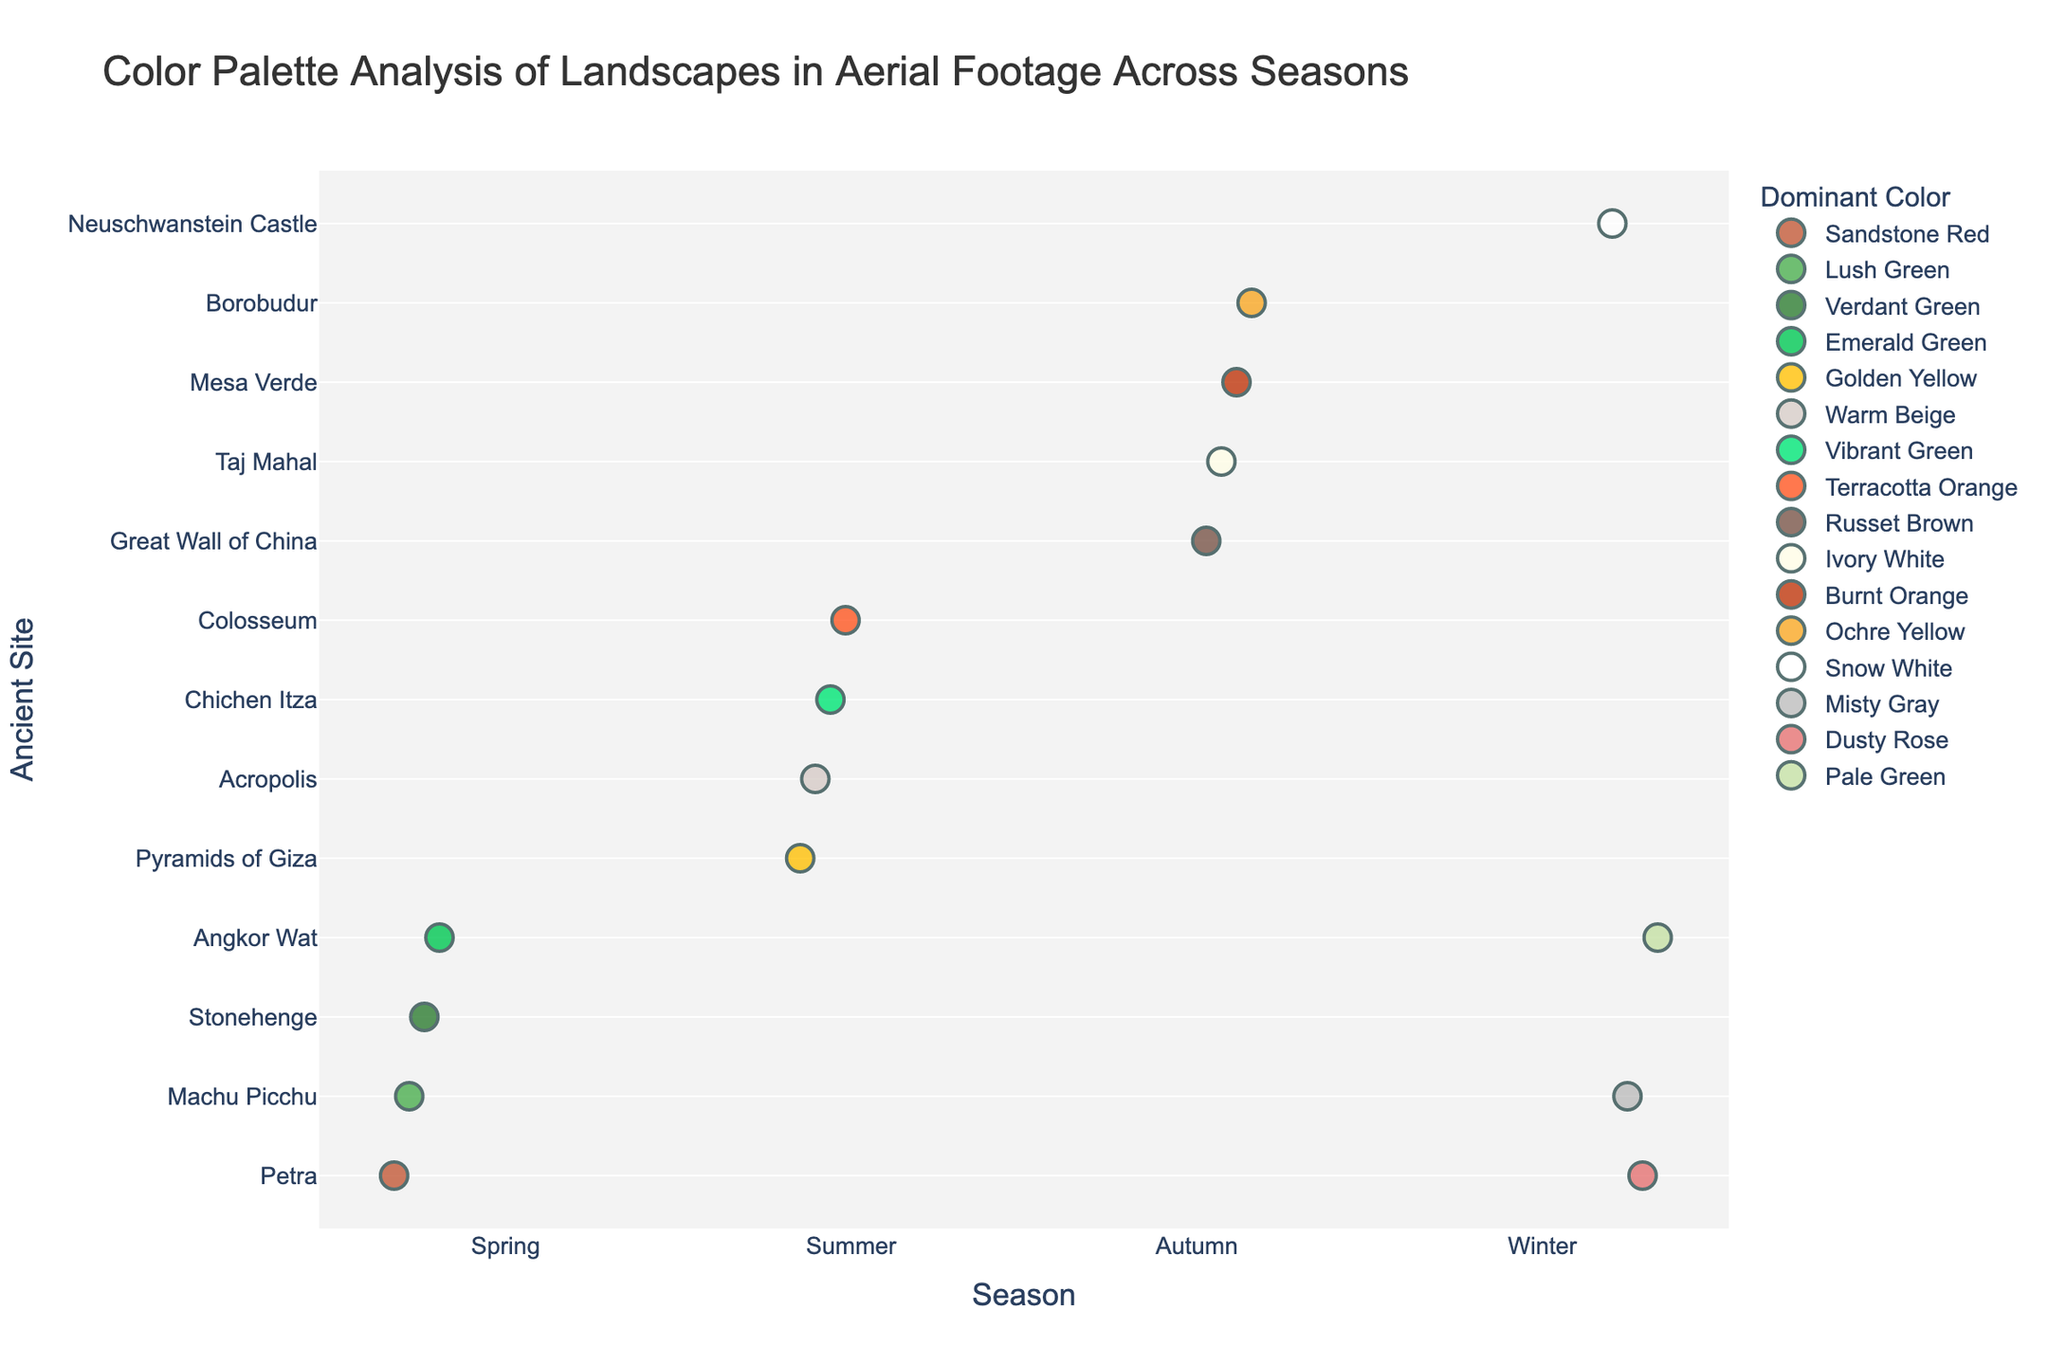What is the title of the plot? The title of the plot is displayed at the top center. It is "Color Palette Analysis of Landscapes in Aerial Footage Across Seasons."
Answer: Color Palette Analysis of Landscapes in Aerial Footage Across Seasons Which season has the most variety of dominant colors? We need to count the number of unique dominant colors in each season. Spring has 4 unique colors (Sandstone Red, Lush Green, Verdant Green, Emerald Green), Summer has 4 (Golden Yellow, Warm Beige, Vibrant Green, Terracotta Orange), Autumn has 4 (Russet Brown, Ivory White, Burnt Orange, Ochre Yellow), and Winter has 4 (Snow White, Misty Gray, Dusty Rose, Pale Green).
Answer: All seasons have the same variety Which ancient site recorded in summer has the warmest color? We can compare the dominant colors of summer. The warmest colors listed are golden yellow (Pyramids of Giza) and warm beige (Acropolis), and golden yellow is generally considered warmer.
Answer: Pyramids of Giza How many ancient sites have "green" as a dominant color in any season? Identify all entries with green-like colors (Lush Green, Verdant Green, Emerald Green, Vibrant Green, Pale Green). The sites are Machu Picchu, Stonehenge, Angkor Wat, Chichen Itza, Angkor Wat (in different seasons). There are 5 entries.
Answer: 5 What is the dominant color for Stonehenge in spring? Locate Stonehenge under the spring season; the corresponding dominant color is "Verdant Green."
Answer: Verdant Green Do any sites repeat in the different seasons, and if so, what are they? Go through the list and identify any repeated ancient sites. Machu Picchu and Petra appear in different seasons (Spring and Winter).
Answer: Machu Picchu and Petra Which dominant color appears only once in the entire dataset? Identify unique dominant colors throughout the dataset. Warm Beige (Acropolis), Ochre Yellow (Borobudur), Misty Gray (Machu Picchu), Dusty Rose (Petra) are the colors that appear only once.
Answer: Warm Beige, Ochre Yellow, Misty Gray, Dusty Rose Does Angkor Wat have the same dominant color in different seasons? Compare the dominant colors for Angkor Wat in spring and in winter. Angkor Wat appears in both Spring (Emerald Green) and Winter (Pale Green)
Answer: No What is the most common dominant color across all seasons? Count the frequency of each dominant color across all seasons. Each color appears exactly once, so there is no most common color.
Answer: No dominant color is most common Which season has the most instances of non-green dominant colors? Count the instances where the dominant color is not related to green for each season. Spring (1 out of 4), Summer (4 out of 4), Autumn (4 out of 4), Winter (3 out of 4).
Answer: Summer and Autumn 